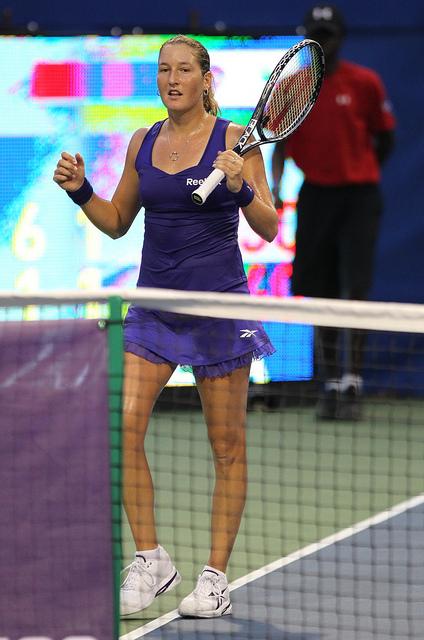What brand are the shoes?
Keep it brief. Nike. Is the player rejoicing?
Be succinct. Yes. Is this young girl swinging a tennis racket at a ball?
Quick response, please. No. What color is the skirt?
Be succinct. Purple. 